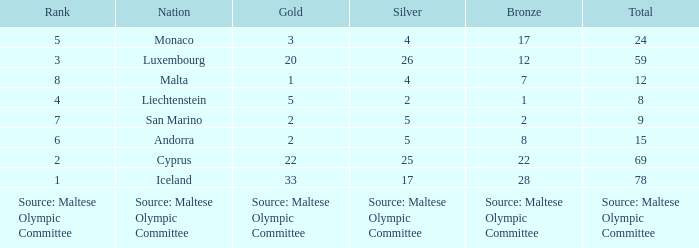What nation has 28 bronze medals? Iceland. 